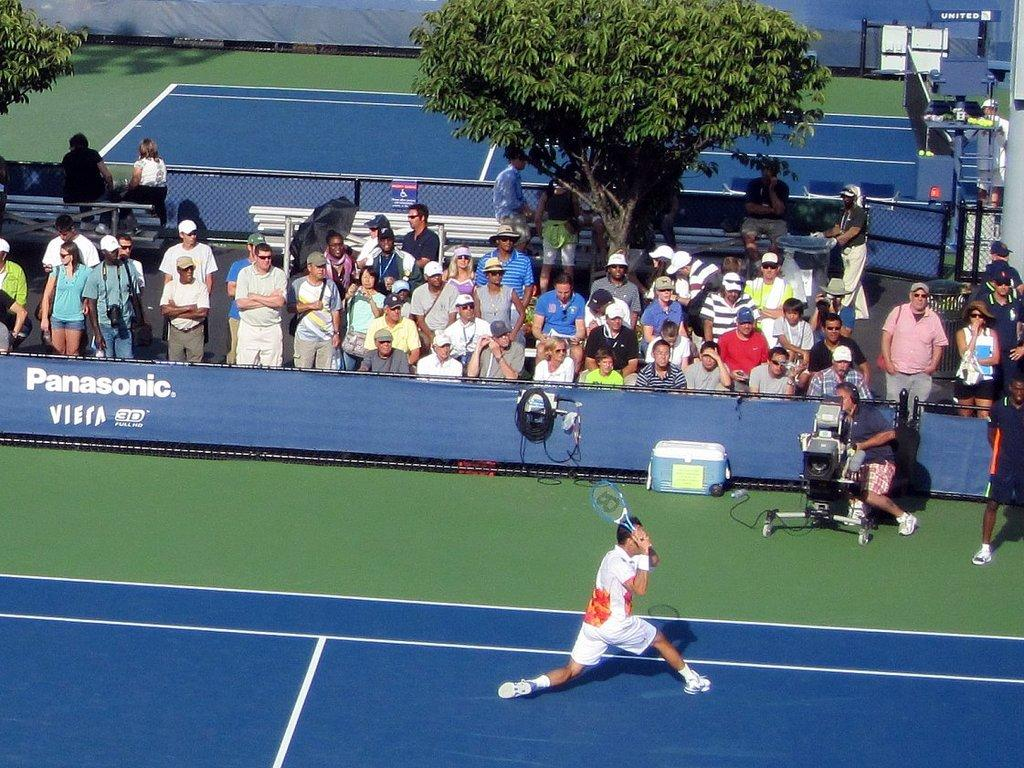What activity is the man in the image engaged in? The man is playing tennis. What can be seen in the background of the image? There are trees, a fence, a group of people, a camera, and a hoarding in the background. Can you describe the setting of the image? The image appears to be a tennis court with trees and a fence in the background. What type of rose is the man holding while playing tennis in the image? There is no rose present in the image. 